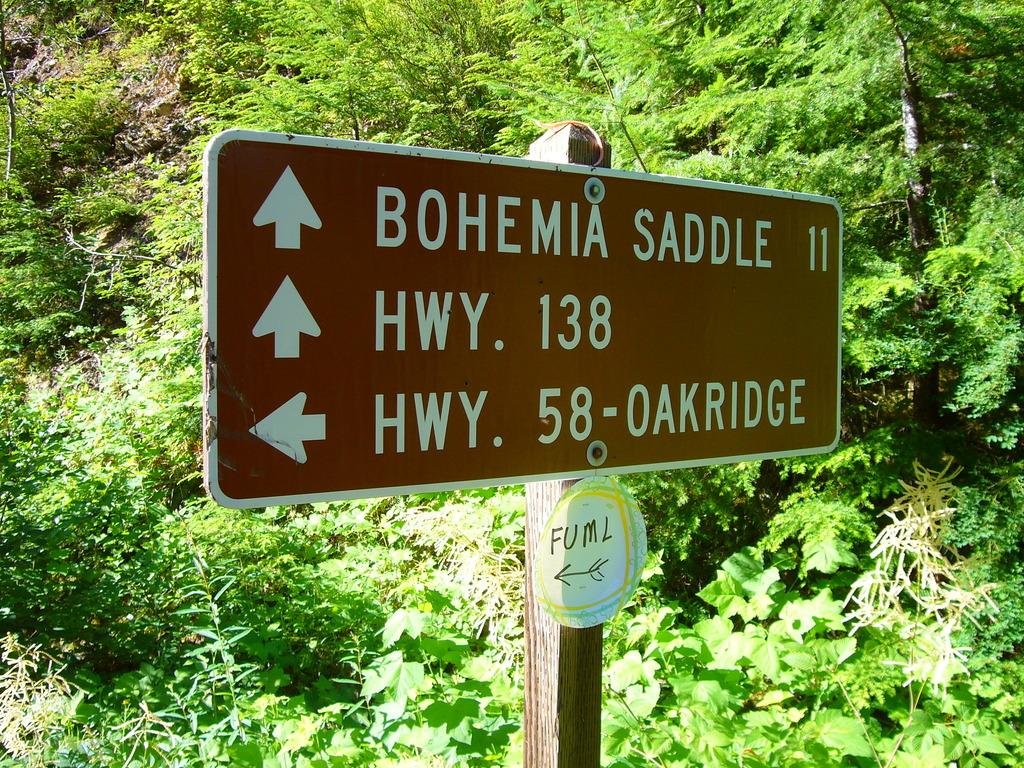What is the main object in the center of the image? There is a board in the center of the image. What can be seen in the background of the image? There are trees in the background of the image. What rule is being enforced by the hand in the image? There is no hand or rule present in the image; it only features a board and trees in the background. 